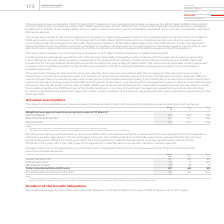From Vodafone Group Plc's financial document, What does the Weighted average actuarial assumptions consist of? The document contains multiple relevant values: Rate of inflation, Rate of increase in salaries, Discount rate. From the document: "verage actuarial assumptions used at 31 March 1 : Rate of inflation 2 2.9 2.9 3.0 Rate of increase in salaries 2.7 2.7 2.6 Discount rate 2.3 2.5 2.6 d..." Also, How much is the 2019 rate of inflation? According to the financial document, 2.9 (percentage). The relevant text states: "umptions used at 31 March 1 : Rate of inflation 2 2.9 2.9 3.0 Rate of increase in salaries 2.7 2.7 2.6 Discount rate 2.3 2.5 2.6..." Also, How much is the 2018 rate of inflation? According to the financial document, 2.9 (percentage). The relevant text states: "umptions used at 31 March 1 : Rate of inflation 2 2.9 2.9 3.0 Rate of increase in salaries 2.7 2.7 2.6 Discount rate 2.3 2.5 2.6..." Also, can you calculate: What is the 2019 average rate of inflation? To answer this question, I need to perform calculations using the financial data. The calculation is: (2.9+2.9)/2, which equals 2.9 (percentage). This is based on the information: "umptions used at 31 March 1 : Rate of inflation 2 2.9 2.9 3.0 Rate of increase in salaries 2.7 2.7 2.6 Discount rate 2.3 2.5 2.6..." Also, can you calculate: What is the 2019 average rate of increase in salaries? To answer this question, I need to perform calculations using the financial data. The calculation is: (2.7+2.7)/2, which equals 2.7 (percentage). This is based on the information: "lation 2 2.9 2.9 3.0 Rate of increase in salaries 2.7 2.7 2.6 Discount rate 2.3 2.5 2.6..." Also, can you calculate: What is the difference between 2019 average rate of inflation and 2019 average rate of increase in salaries? To answer this question, I need to perform calculations using the financial data. The calculation is: [(2.9+2.9)/2] - [(2.7+2.7)/2], which equals 0.2 (percentage). This is based on the information: "lation 2 2.9 2.9 3.0 Rate of increase in salaries 2.7 2.7 2.6 Discount rate 2.3 2.5 2.6 173 Vodafone Group Plc Annual Report 2019 umptions used at 31 March 1 : Rate of inflation 2 2.9 2.9 3.0 Rate of ..." The key data points involved are: 2.7, 2.9. 